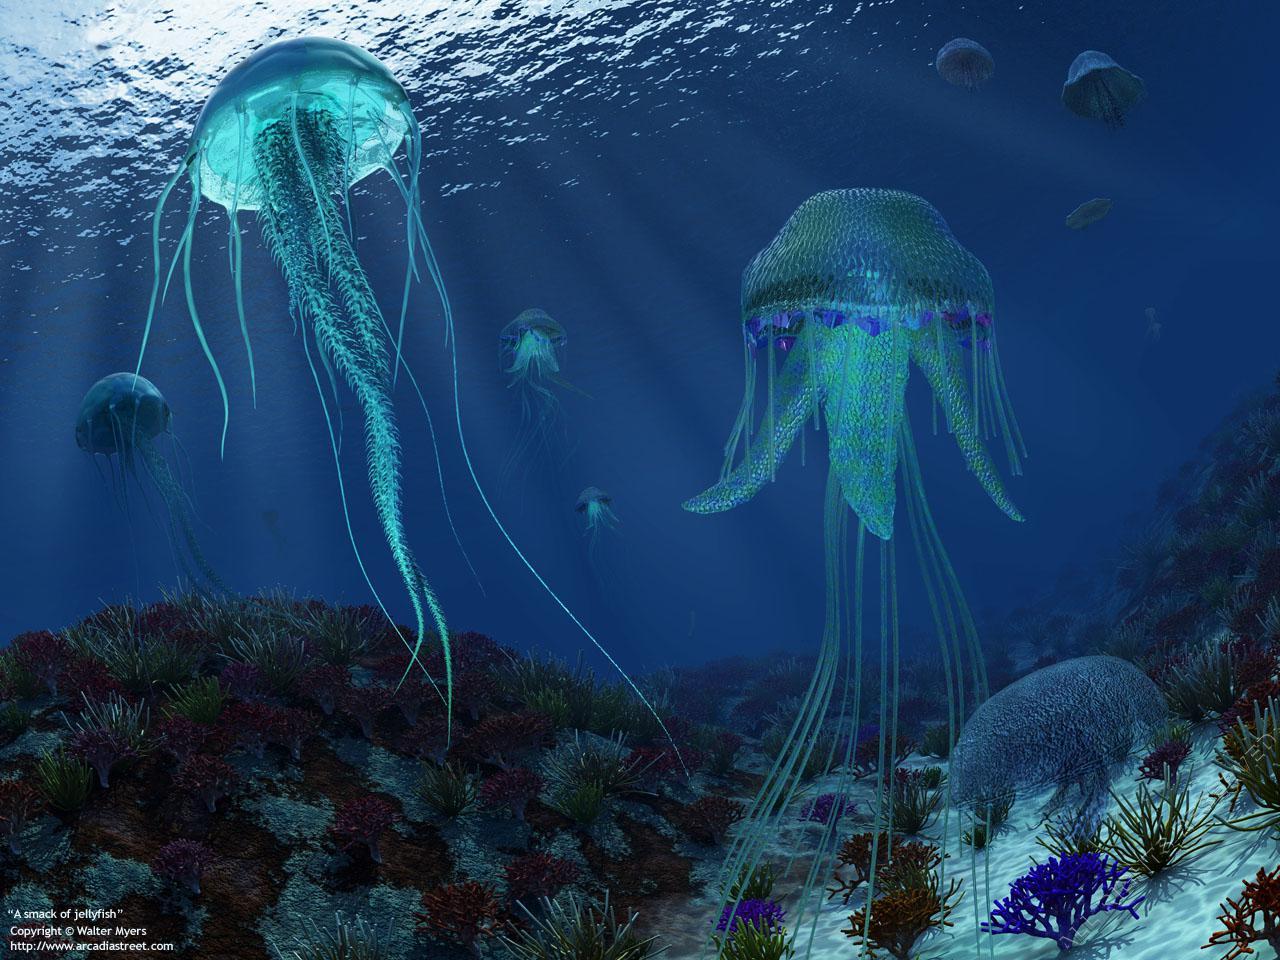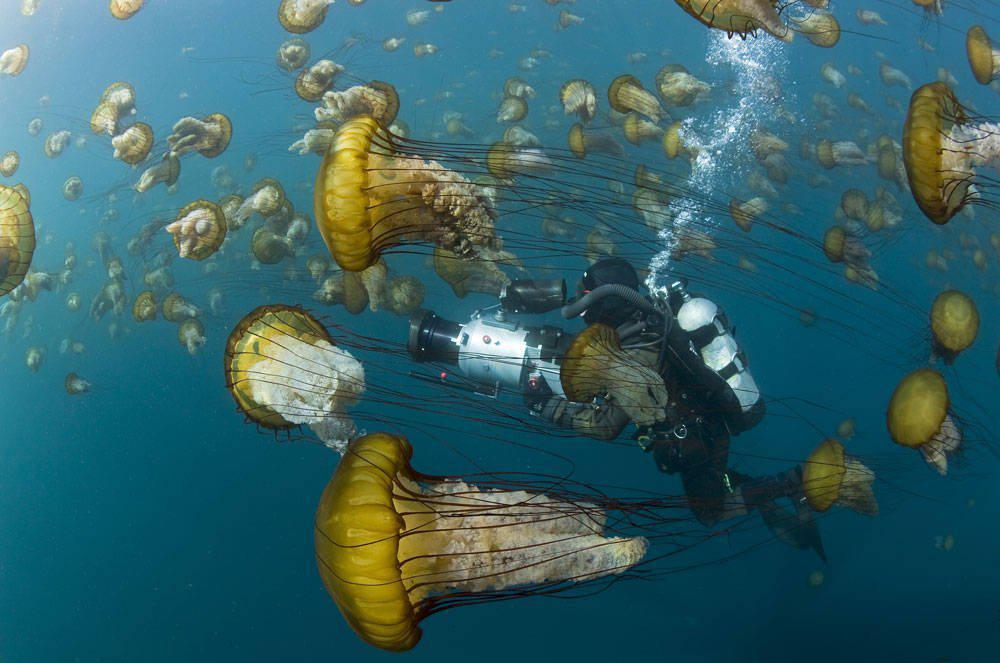The first image is the image on the left, the second image is the image on the right. For the images shown, is this caption "An image shows just one jellyfish, which has long, non-curly tendrils." true? Answer yes or no. No. The first image is the image on the left, the second image is the image on the right. Analyze the images presented: Is the assertion "In one of the images, a single jellyfish floats on its side" valid? Answer yes or no. No. 